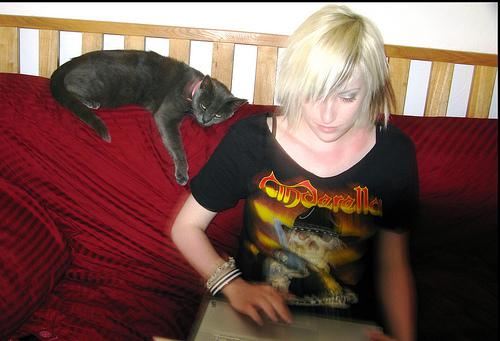Question: how is the cat laying?
Choices:
A. On the floor.
B. On the chair.
C. On top of the couch.
D. On top of the TV.
Answer with the letter. Answer: C Question: where are they sitting?
Choices:
A. In chairs.
B. On the ground.
C. On a couch.
D. On a bench.
Answer with the letter. Answer: C Question: what band is on her t-shirt?
Choices:
A. Nickleback.
B. Cinderella.
C. The Band Perry.
D. The Zac Brown Band.
Answer with the letter. Answer: B Question: what color is the woman's hair?
Choices:
A. Black.
B. Brown.
C. Grey.
D. Blonde.
Answer with the letter. Answer: D Question: what is the woman doing?
Choices:
A. Gardening.
B. Walking.
C. Using a laptop.
D. Sleeping.
Answer with the letter. Answer: C 